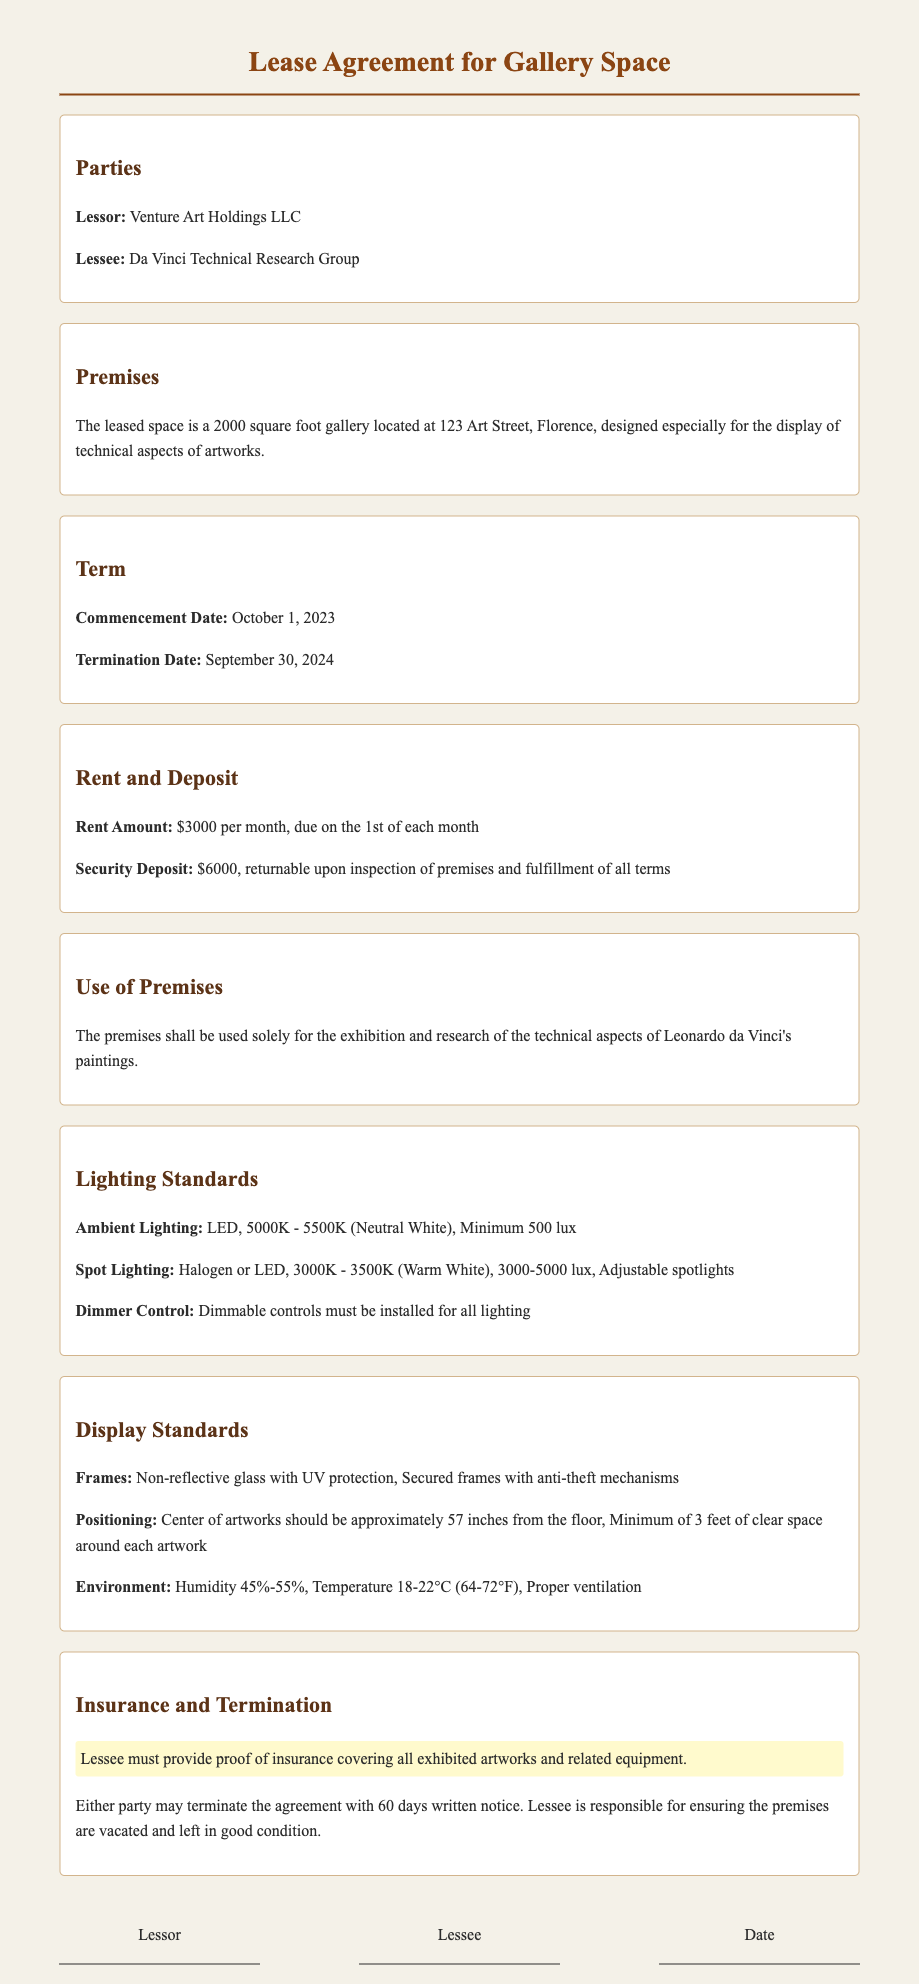What is the name of the Lessor? The name of the Lessor is specified in the "Parties" section of the document.
Answer: Venture Art Holdings LLC What is the square footage of the gallery space? The square footage is mentioned in the "Premises" section, specifying the size of the leased space.
Answer: 2000 square foot What is the rent amount per month? The monthly rent amount is outlined in the "Rent and Deposit" section of the document.
Answer: $3000 What is the humidity range required for the environment? The required humidity range is detailed in the "Display Standards" section.
Answer: 45%-55% What is the commencement date of the lease? The commencement date is clearly stated in the "Term" section of the document.
Answer: October 1, 2023 What type of glass should be used for frames? The type of glass required for frames is specified in the "Display Standards" section.
Answer: Non-reflective glass with UV protection How much notice is required to terminate the agreement? The notice period for termination is noted in the "Insurance and Termination" section of the document.
Answer: 60 days What is the minimum lighting lux for ambient lighting? The minimum lux requirement for ambient lighting is mentioned in the "Lighting Standards" section.
Answer: 500 lux What temperature range should the environment maintain? The temperature range is specified in the "Display Standards" section of the document.
Answer: 18-22°C (64-72°F) 